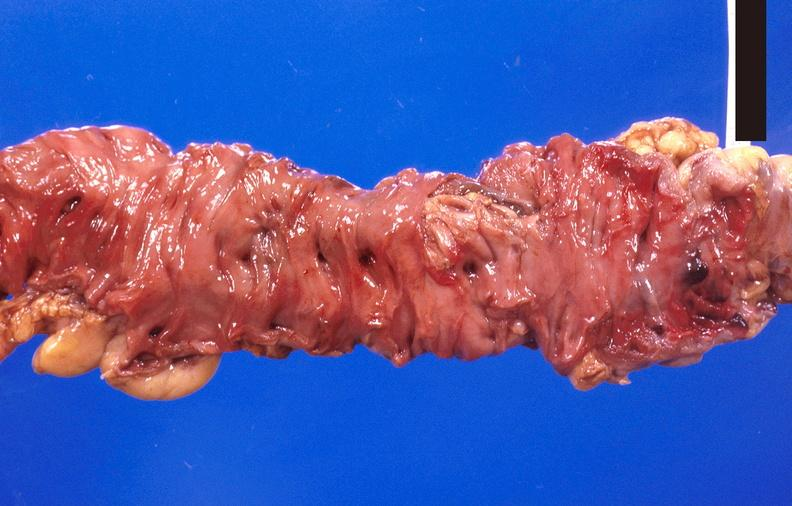what does this image show?
Answer the question using a single word or phrase. Colon polyposis 